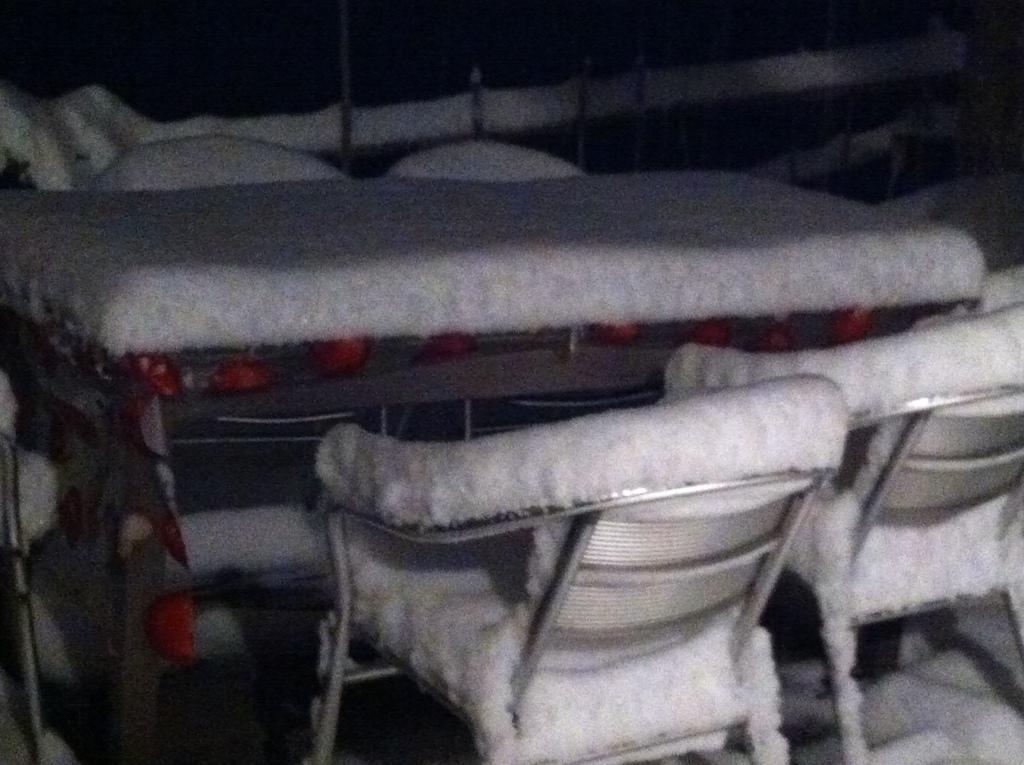Describe this image in one or two sentences. In this picture we can see a table, chairs on the ground, here we can see some objects and in the background we can see it is dark. 